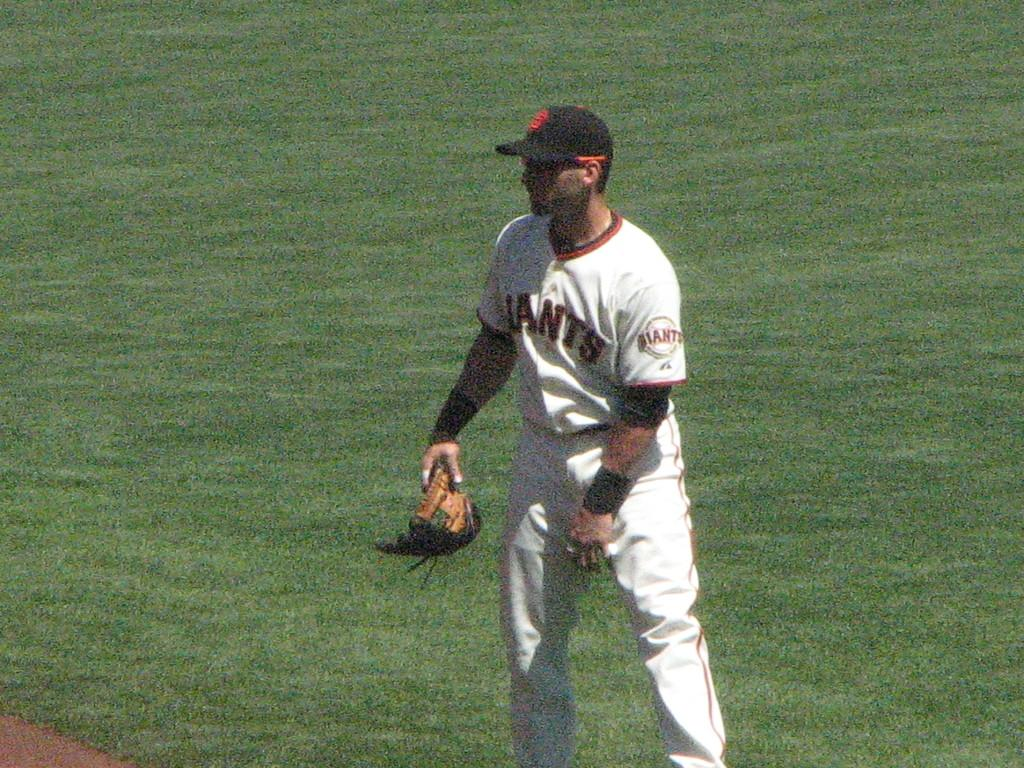<image>
Provide a brief description of the given image. The Giants player is holding his glove in his hand rather than being baseball ready. 